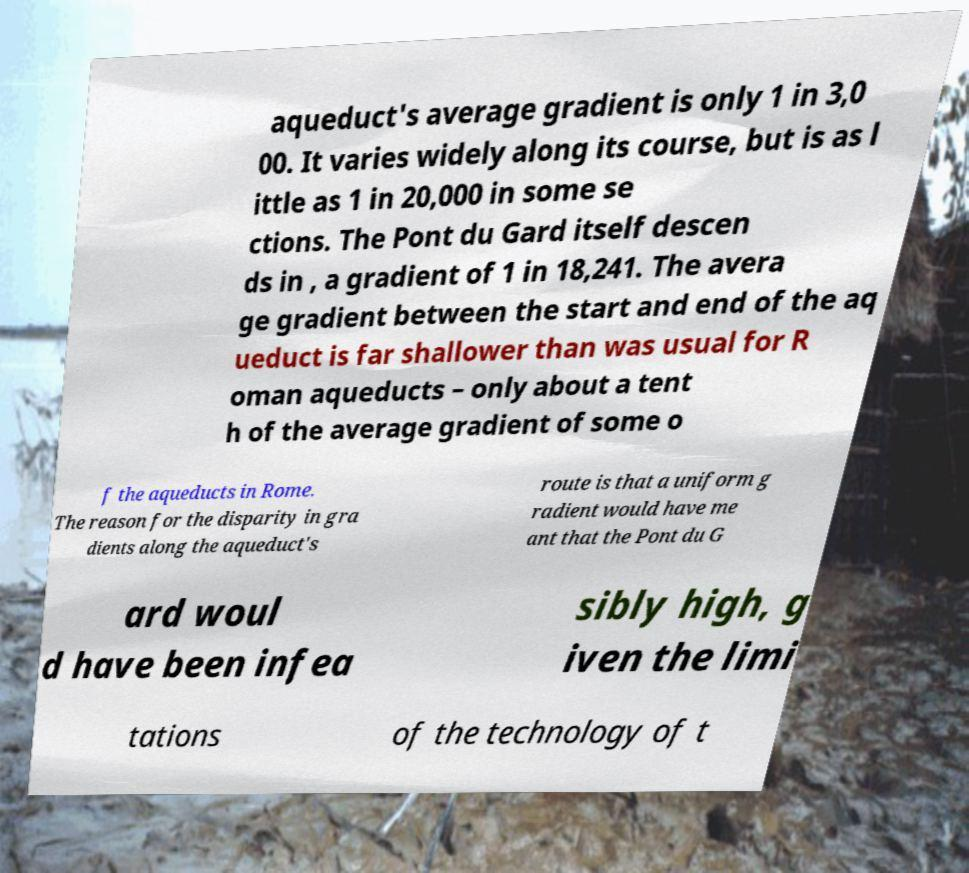Please read and relay the text visible in this image. What does it say? aqueduct's average gradient is only 1 in 3,0 00. It varies widely along its course, but is as l ittle as 1 in 20,000 in some se ctions. The Pont du Gard itself descen ds in , a gradient of 1 in 18,241. The avera ge gradient between the start and end of the aq ueduct is far shallower than was usual for R oman aqueducts – only about a tent h of the average gradient of some o f the aqueducts in Rome. The reason for the disparity in gra dients along the aqueduct's route is that a uniform g radient would have me ant that the Pont du G ard woul d have been infea sibly high, g iven the limi tations of the technology of t 